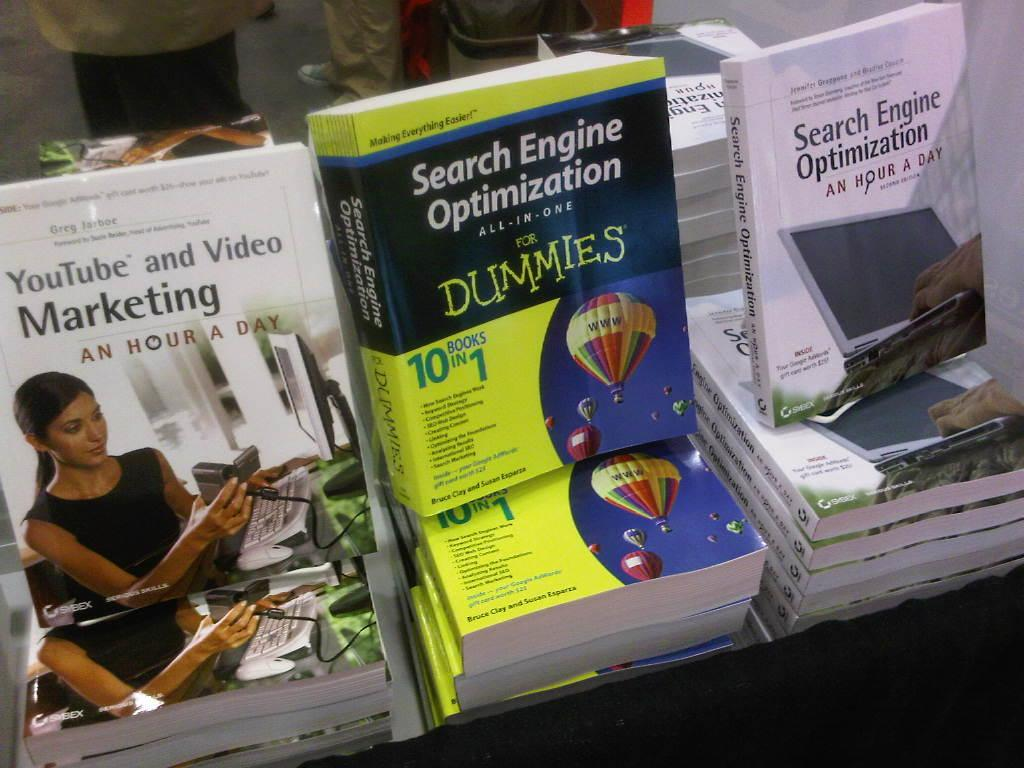<image>
Offer a succinct explanation of the picture presented. Books about Internet marketing are on display at a store. 